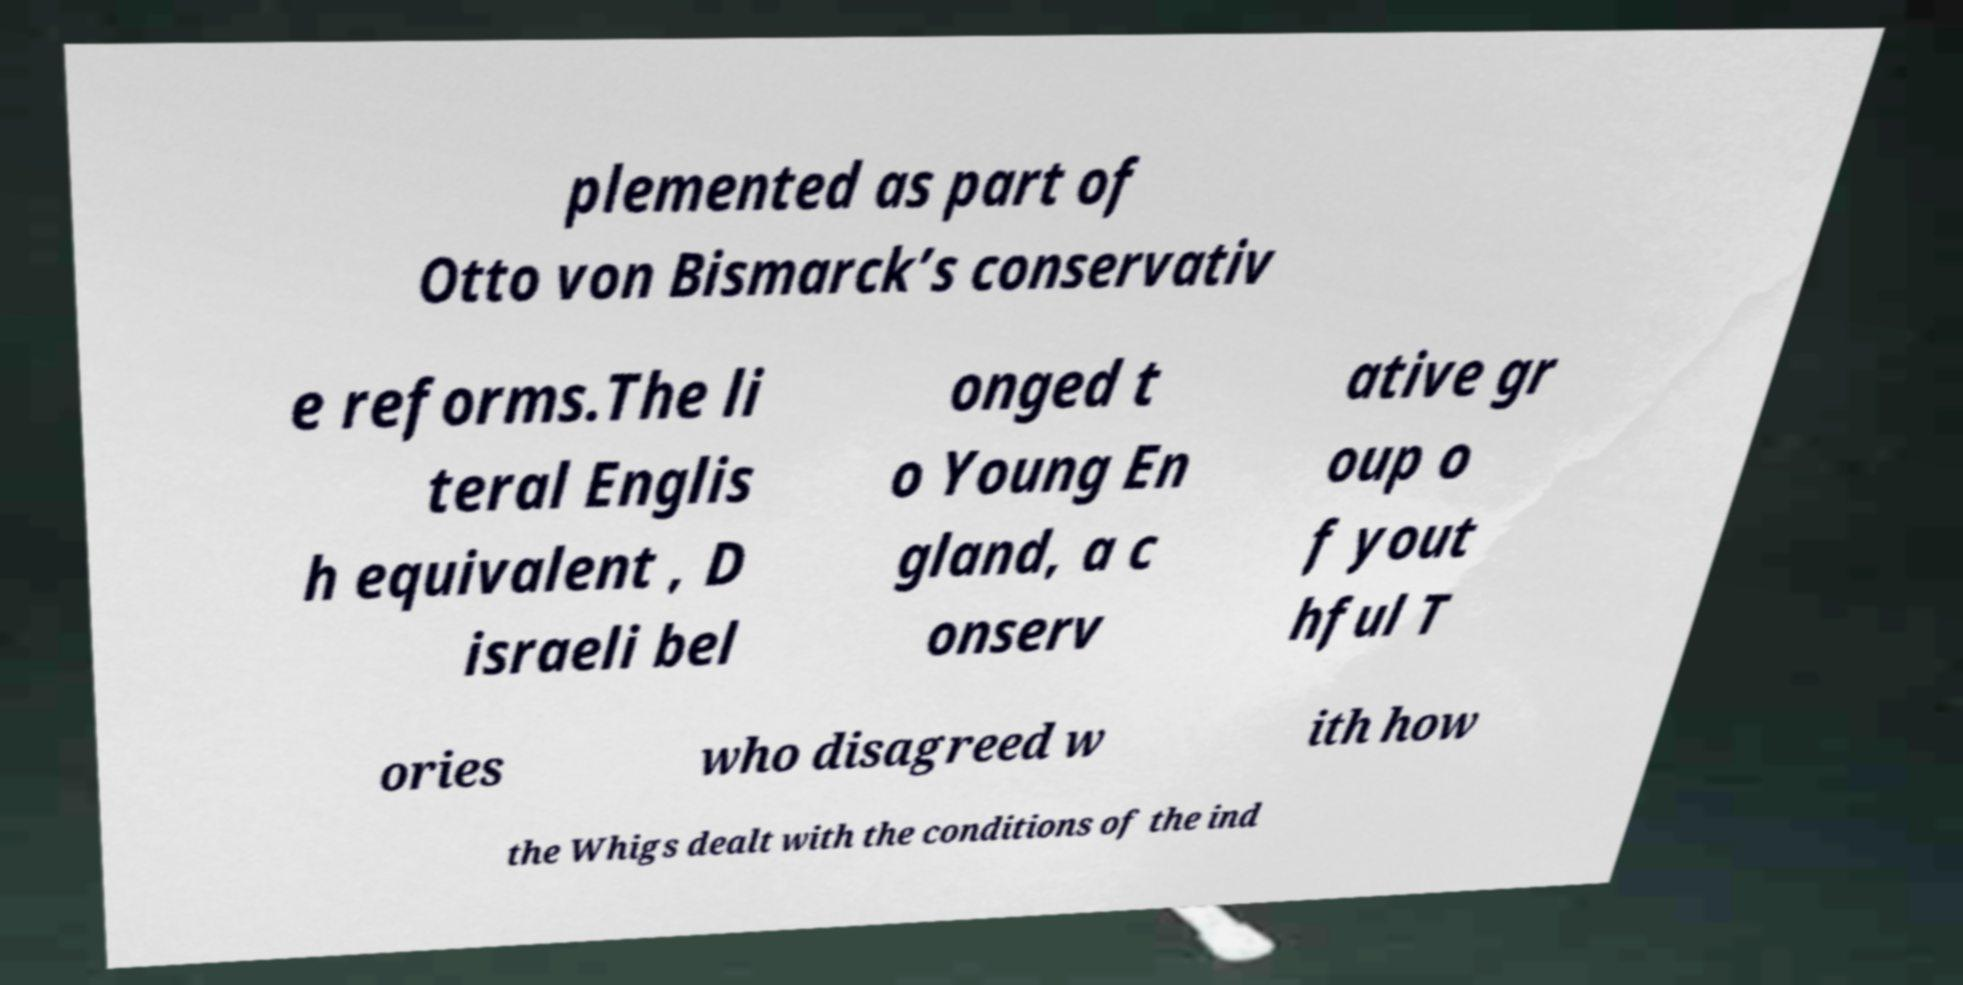Please identify and transcribe the text found in this image. plemented as part of Otto von Bismarck’s conservativ e reforms.The li teral Englis h equivalent , D israeli bel onged t o Young En gland, a c onserv ative gr oup o f yout hful T ories who disagreed w ith how the Whigs dealt with the conditions of the ind 